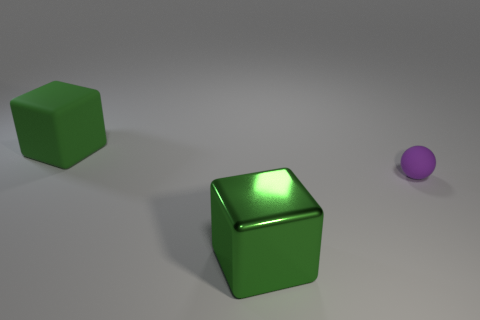How many green blocks must be subtracted to get 1 green blocks? 1 Subtract all blue spheres. Subtract all cyan cylinders. How many spheres are left? 1 Add 3 green metallic blocks. How many objects exist? 6 Subtract all spheres. How many objects are left? 2 Add 1 rubber cubes. How many rubber cubes exist? 2 Subtract 0 brown cylinders. How many objects are left? 3 Subtract all big green blocks. Subtract all large matte spheres. How many objects are left? 1 Add 2 matte things. How many matte things are left? 4 